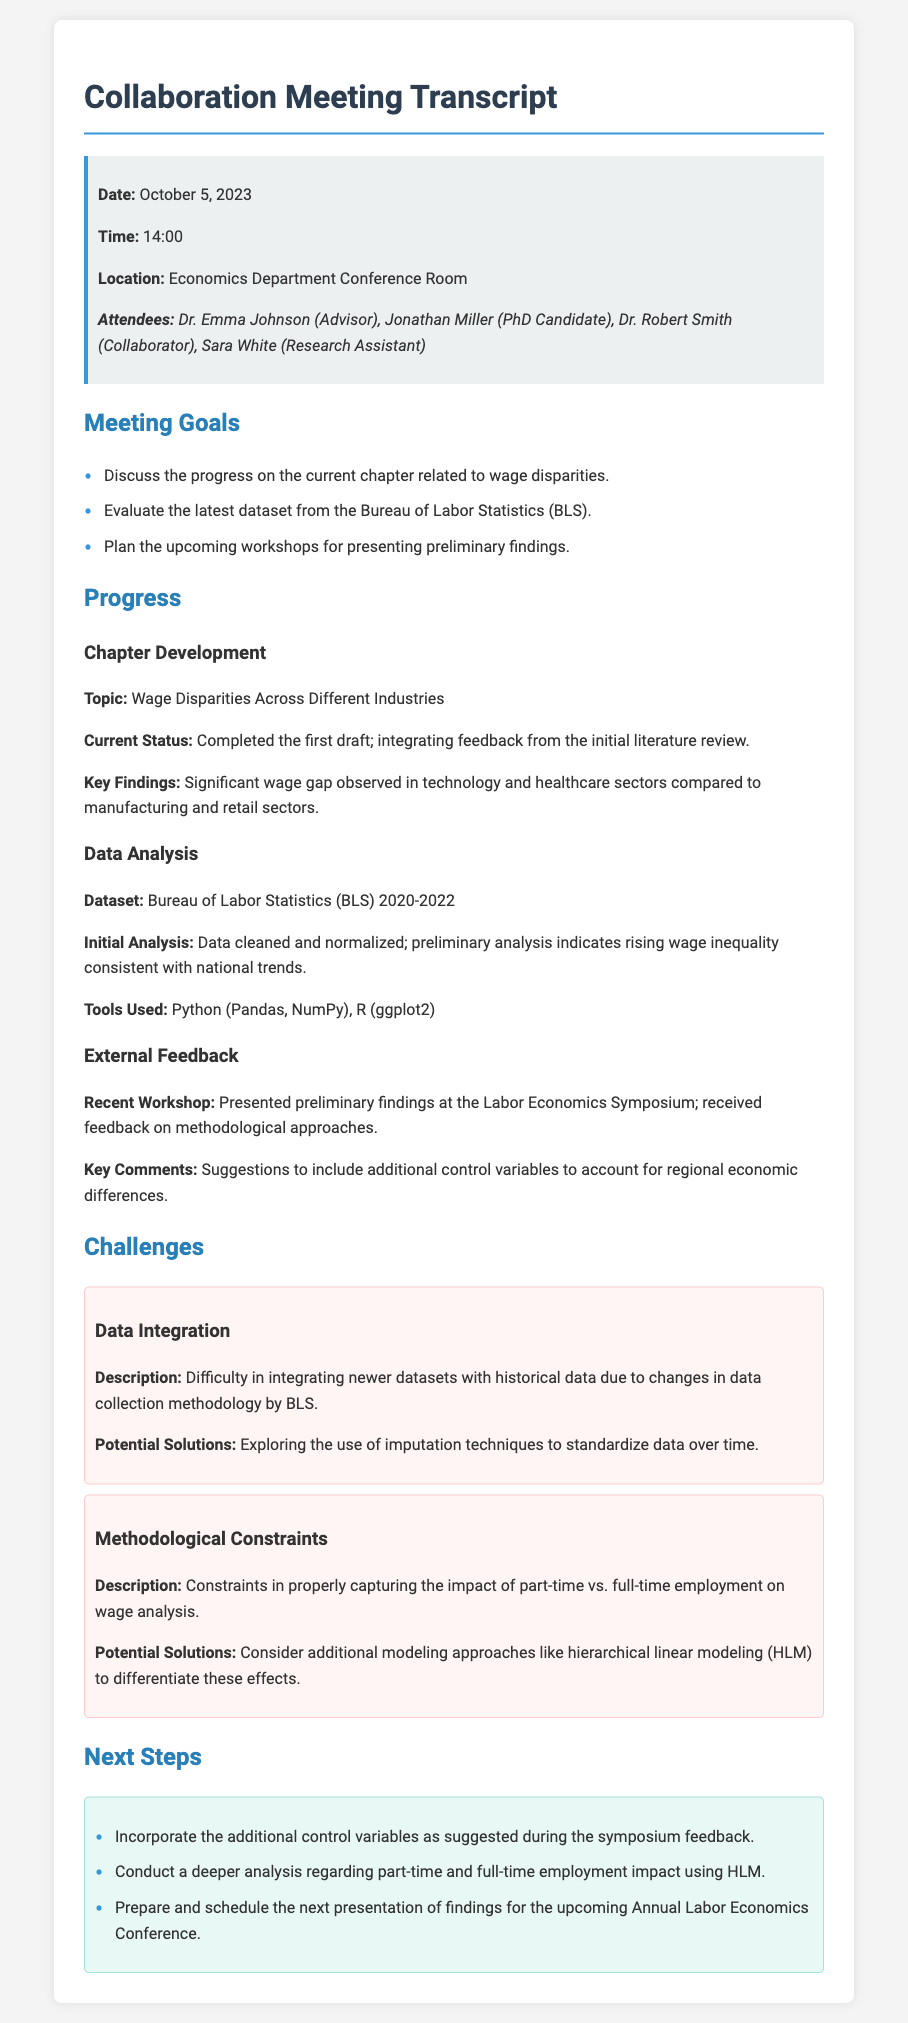What was the date of the meeting? The date of the meeting is mentioned in the meeting details section.
Answer: October 5, 2023 Who are the attendees of the meeting? The attendees are listed in the meeting details section, including their roles.
Answer: Dr. Emma Johnson, Jonathan Miller, Dr. Robert Smith, Sara White What topic was discussed in relation to wage disparities? The specific topic is highlighted under chapter development in the progress section.
Answer: Wage Disparities Across Different Industries What major challenge was identified regarding data? The challenges are described in a dedicated section of the document.
Answer: Data Integration What is the primary analytical tool used for data analysis? Tools used for data analysis are listed in the progress section.
Answer: Python, R What additional modeling approach is suggested to differentiate employment impact? The proposed solution for addressing methodological constraints is highlighted in the challenges section.
Answer: Hierarchical linear modeling (HLM) What is the current status of the chapter development? The current status is specified in the chapter development progress item.
Answer: Completed the first draft How did the attendees gather feedback on their findings? The method of gathering feedback is indicated in the external feedback section.
Answer: Labor Economics Symposium What is the next step regarding the findings presentation? The next steps include preparing for an upcoming conference as indicated in the next steps section.
Answer: Upcoming Annual Labor Economics Conference 